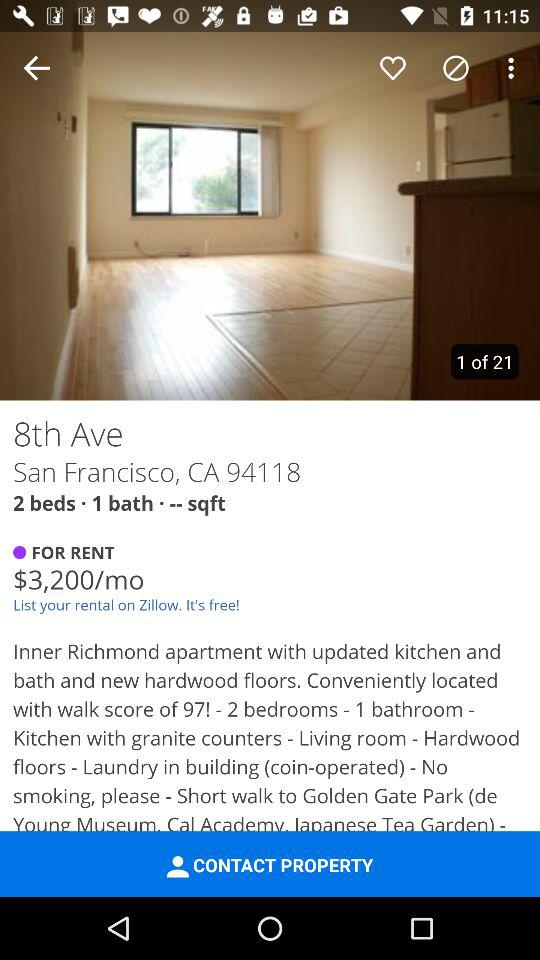How many bedrooms are there in the apartment?
Answer the question using a single word or phrase. 2 